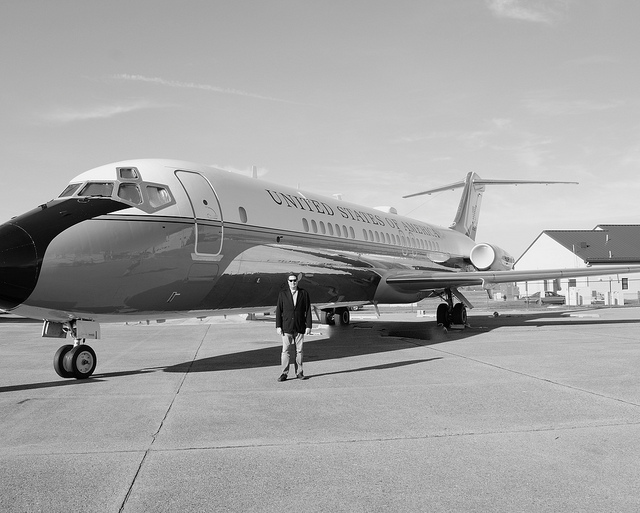Read and extract the text from this image. UNITED STATUS OF 